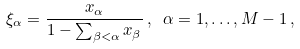Convert formula to latex. <formula><loc_0><loc_0><loc_500><loc_500>\xi _ { \alpha } = \frac { x _ { \alpha } } { 1 - \sum _ { \beta < \alpha } x _ { \beta } } \, , \ \alpha = 1 , \dots , M - 1 \, ,</formula> 